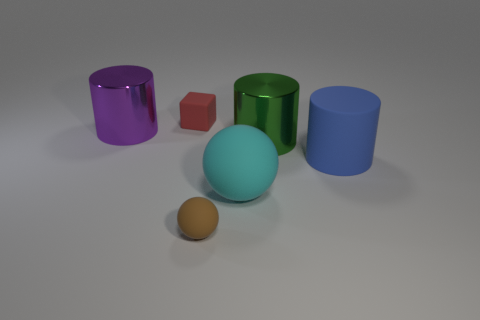Add 3 red cubes. How many objects exist? 9 Subtract all green metallic cylinders. How many cylinders are left? 2 Subtract all spheres. How many objects are left? 4 Add 5 brown rubber spheres. How many brown rubber spheres are left? 6 Add 5 big cyan rubber cylinders. How many big cyan rubber cylinders exist? 5 Subtract 1 blue cylinders. How many objects are left? 5 Subtract all cyan cylinders. Subtract all brown spheres. How many cylinders are left? 3 Subtract all large cylinders. Subtract all big cylinders. How many objects are left? 0 